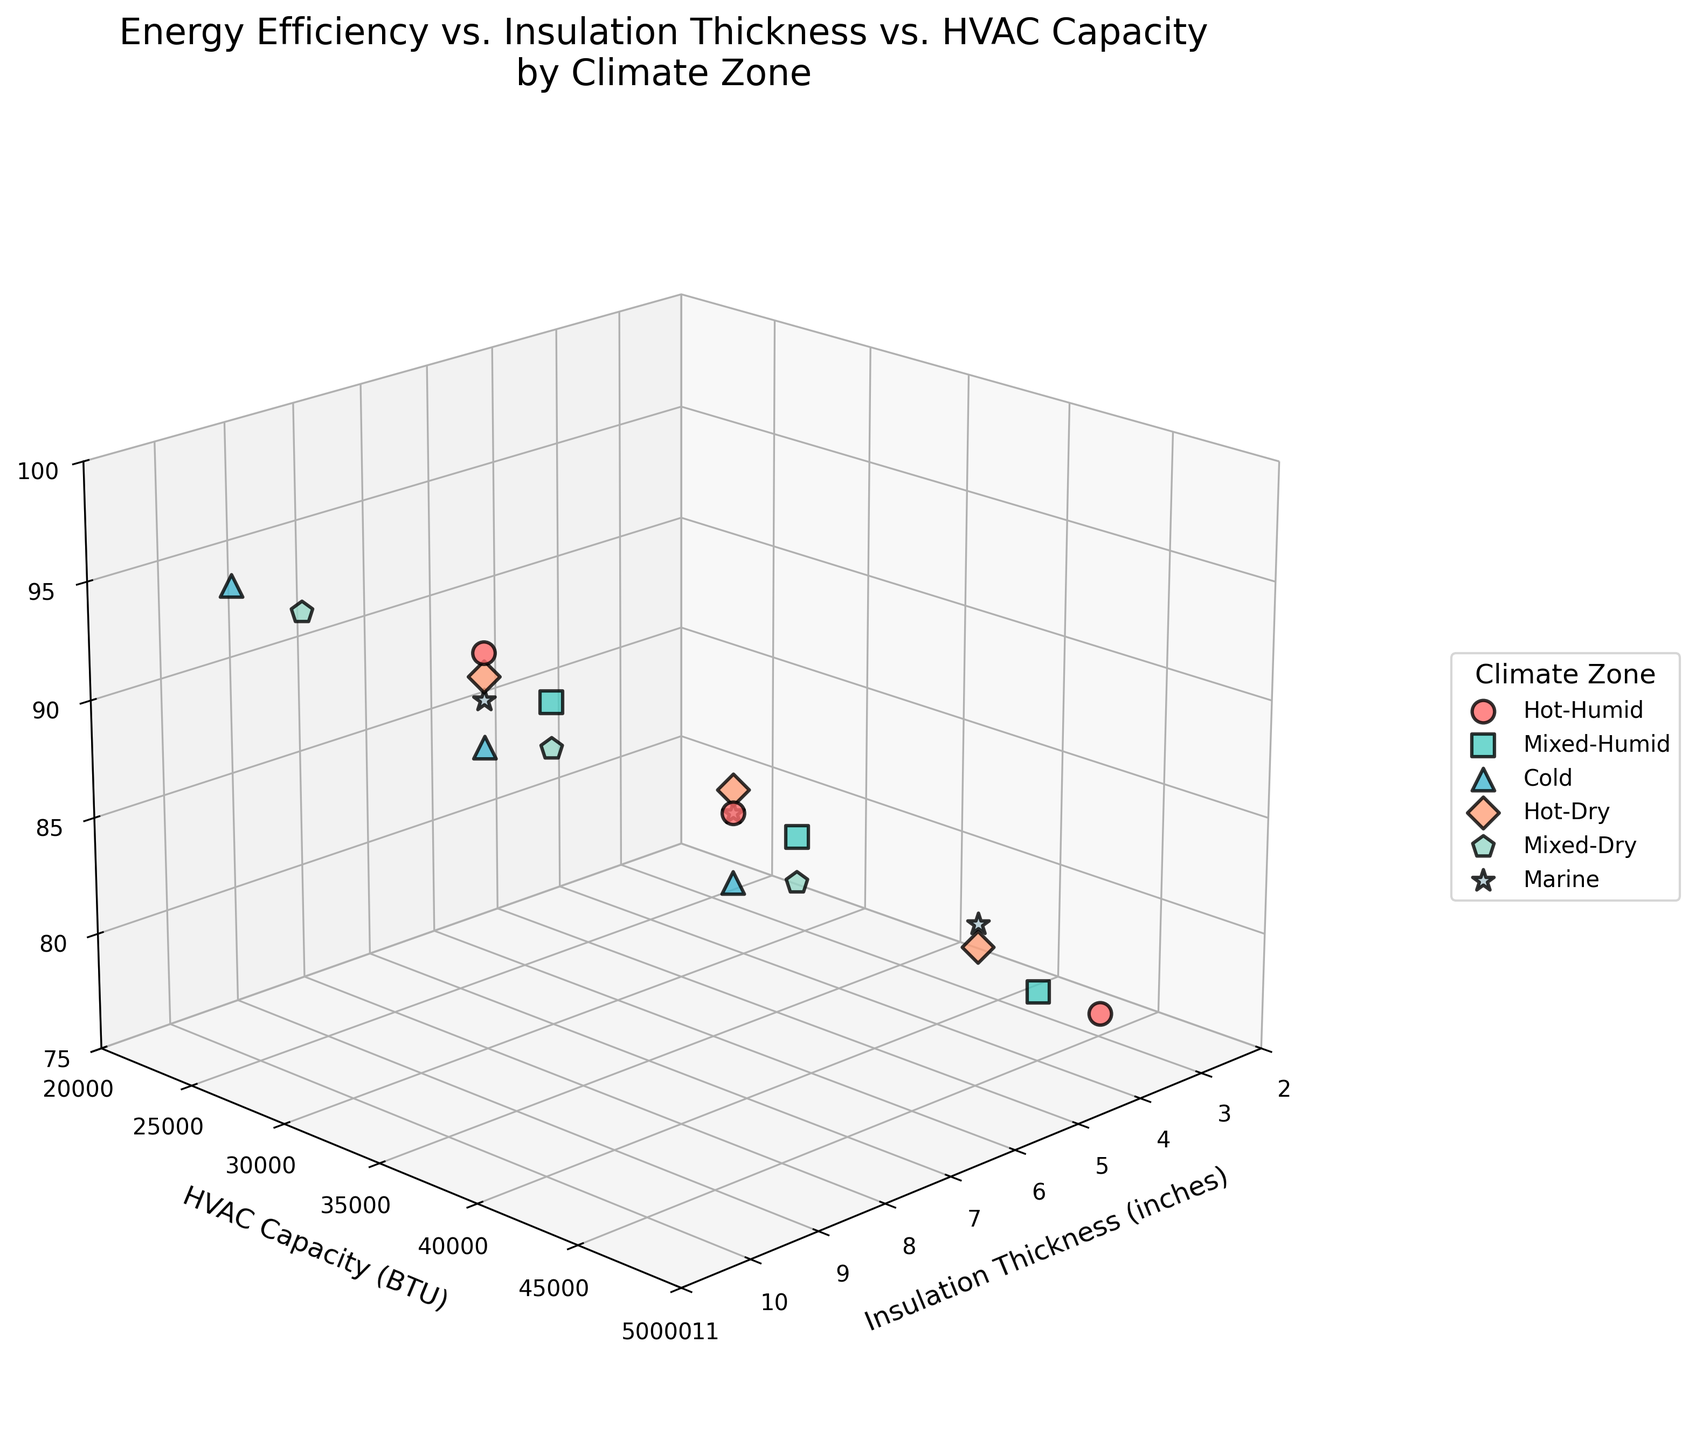What is the title of the plot? The title of the plot is written at the top center of the figure. It summarizes the purpose of the plot: showing the relationship between energy efficiency rating, insulation thickness, and HVAC capacity across different climate zones.
Answer: "Energy Efficiency vs. Insulation Thickness vs. HVAC Capacity by Climate Zone" What are the axes labels in the plot? Axes labels are displayed along each axis. The x-axis is labeled "Insulation Thickness (inches)", the y-axis is labeled "HVAC Capacity (BTU)", and the z-axis is labeled "Energy Efficiency Rating".
Answer: Insulation Thickness (inches), HVAC Capacity (BTU), Energy Efficiency Rating What color is used for data points in the Cold climate zone? By looking at the legend, we can see that the Cold climate zone is mapped to a certain color. This color is used consistently for all data points in that zone within the plot.
Answer: Light blue Which climate zone has the highest energy efficiency rating and what is that rating? The energy efficiency rating is shown on the z-axis. We look for the highest point on this axis and then check the corresponding climate zone using the color and marker shape from the legend.
Answer: Cold, 95 Comparing Hot-Humid and Cold zones, which has higher average insulation thickness? To find the average insulation thickness for each zone, we consider the x-axis values for each data point in the Hot-Humid and Cold zones, sum them up separately and divide by the number of points.
Answer: Cold How many data points are there for each climate zone? We count the different data points for each climate zone using the legend to identify the color and marker shape associated with each zone.
Answer: 3 Is there a clear correlation between insulation thickness and HVAC capacity for all climate zones? We observe the pattern of data points for each climate zone as they relate to the x-axis and y-axis. If a correlation exists, the data points should form a discernible trend or line.
Answer: No What is a general trend in energy efficiency ratings among the different climate zones? By observing the z-axis values across different climate zones, we examine if higher or lower ratings cluster consistently within certain climate zones.
Answer: Generally higher in Cold and lower in Mixed-Humid Which climate zone has the most diverse range of HVAC capacities? We look at the y-axis values for each zone and identify which range of values is the widest among them by observing the spread of the data points along the y-axis.
Answer: Marine Are there any climate zones where increased insulation thickness does not lead to higher energy efficiency ratings? We compare the insulation thickness on the x-axis to the energy efficiency rating on the z-axis for each zone and look for any zones where higher thickness doesn't consistently lead to higher ratings.
Answer: Mixed-Humid 